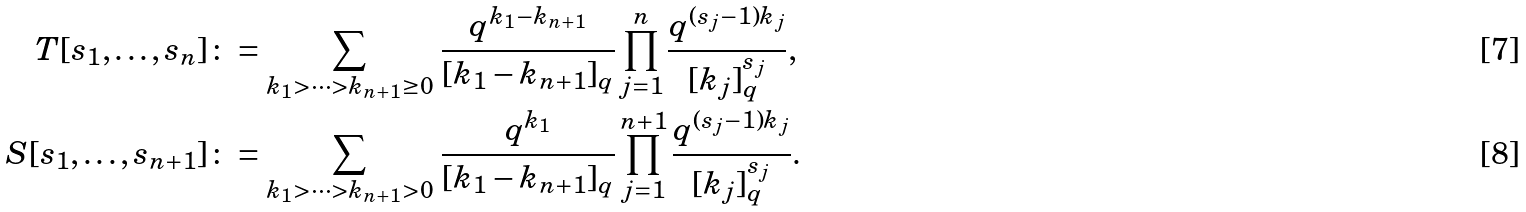Convert formula to latex. <formula><loc_0><loc_0><loc_500><loc_500>T [ s _ { 1 } , \dots , s _ { n } ] & \colon = \sum _ { k _ { 1 } > \cdots > k _ { n + 1 } \geq 0 } \, \frac { q ^ { k _ { 1 } - k _ { n + 1 } } } { [ k _ { 1 } - k _ { n + 1 } ] _ { q } } \prod _ { j = 1 } ^ { n } \frac { q ^ { ( s _ { j } - 1 ) k _ { j } } } { [ k _ { j } ] _ { q } ^ { s _ { j } } } , \\ S [ s _ { 1 } , \dots , s _ { n + 1 } ] & \colon = \sum _ { k _ { 1 } > \cdots > k _ { n + 1 } > 0 } \, \frac { q ^ { k _ { 1 } } } { [ k _ { 1 } - k _ { n + 1 } ] _ { q } } \prod _ { j = 1 } ^ { n + 1 } \frac { q ^ { ( s _ { j } - 1 ) k _ { j } } } { [ k _ { j } ] _ { q } ^ { s _ { j } } } .</formula> 